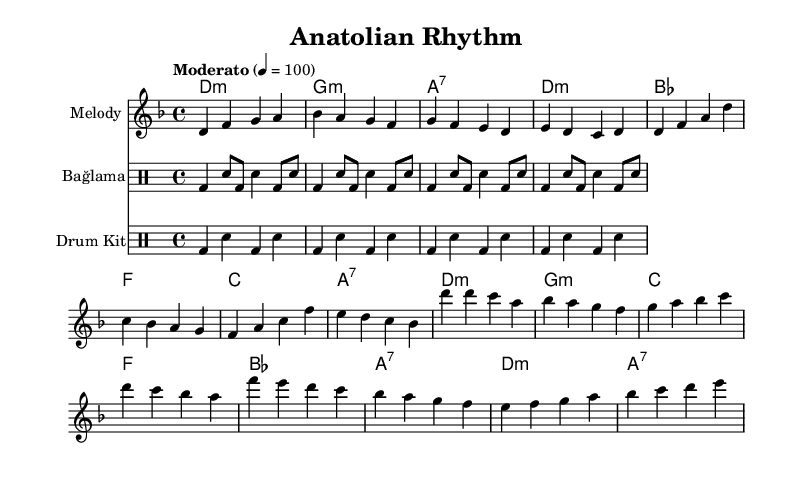What is the key signature of this music? The key signature is D minor, which is represented by one flat (B flat) in the key signature section of the sheet music.
Answer: D minor What is the time signature of the piece? The time signature is 4/4, which indicates four beats in each measure and a quarter note receives one beat. This is shown at the beginning of the staff.
Answer: 4/4 What is the tempo marking of the score? The tempo marking indicates "Moderato," which typically suggests a moderate pace. The specific beats per minute are also indicated as "4 = 100," guiding the performer on the speed.
Answer: Moderato How many measures are in the intro section? The intro section consists of four measures, as noted by the grouping of notes at the beginning of the melody line. This is counted by observing the rhythm patterns in the first part of the score.
Answer: 4 What instrument is used for the traditional Turkish rhythm in this score? The traditional Turkish rhythm is represented by the "Bağlama," which is a stringed instrument that appears in the drum staff section, denoting a distinct pattern associated with traditional music.
Answer: Bağlama What type of chords are used in the harmony section? The harmony section consists of minor and seventh chords, as indicated by their notations such as "d:m" for D minor and "a:7" for A7, which showcase the characteristic sound used in K-Pop melodies.
Answer: Minor and seventh chords How many different instruments are featured in this score? There are three different instruments featured: one for the melody (notated as "Melody"), one for the traditional Bağlama rhythm, and one for the modern drum kit, showcasing a blend of traditional and contemporary sounds.
Answer: 3 